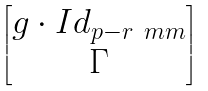Convert formula to latex. <formula><loc_0><loc_0><loc_500><loc_500>\begin{bmatrix} g \cdot I d _ { p - r _ { \ } m m } \\ \Gamma \end{bmatrix}</formula> 